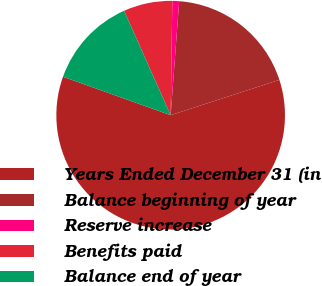Convert chart to OTSL. <chart><loc_0><loc_0><loc_500><loc_500><pie_chart><fcel>Years Ended December 31 (in<fcel>Balance beginning of year<fcel>Reserve increase<fcel>Benefits paid<fcel>Balance end of year<nl><fcel>60.46%<fcel>18.81%<fcel>0.96%<fcel>6.91%<fcel>12.86%<nl></chart> 